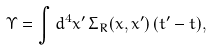<formula> <loc_0><loc_0><loc_500><loc_500>\Upsilon = \int d ^ { 4 } x ^ { \prime } \, \Sigma _ { R } ( x , x ^ { \prime } ) \, ( t ^ { \prime } - t ) ,</formula> 